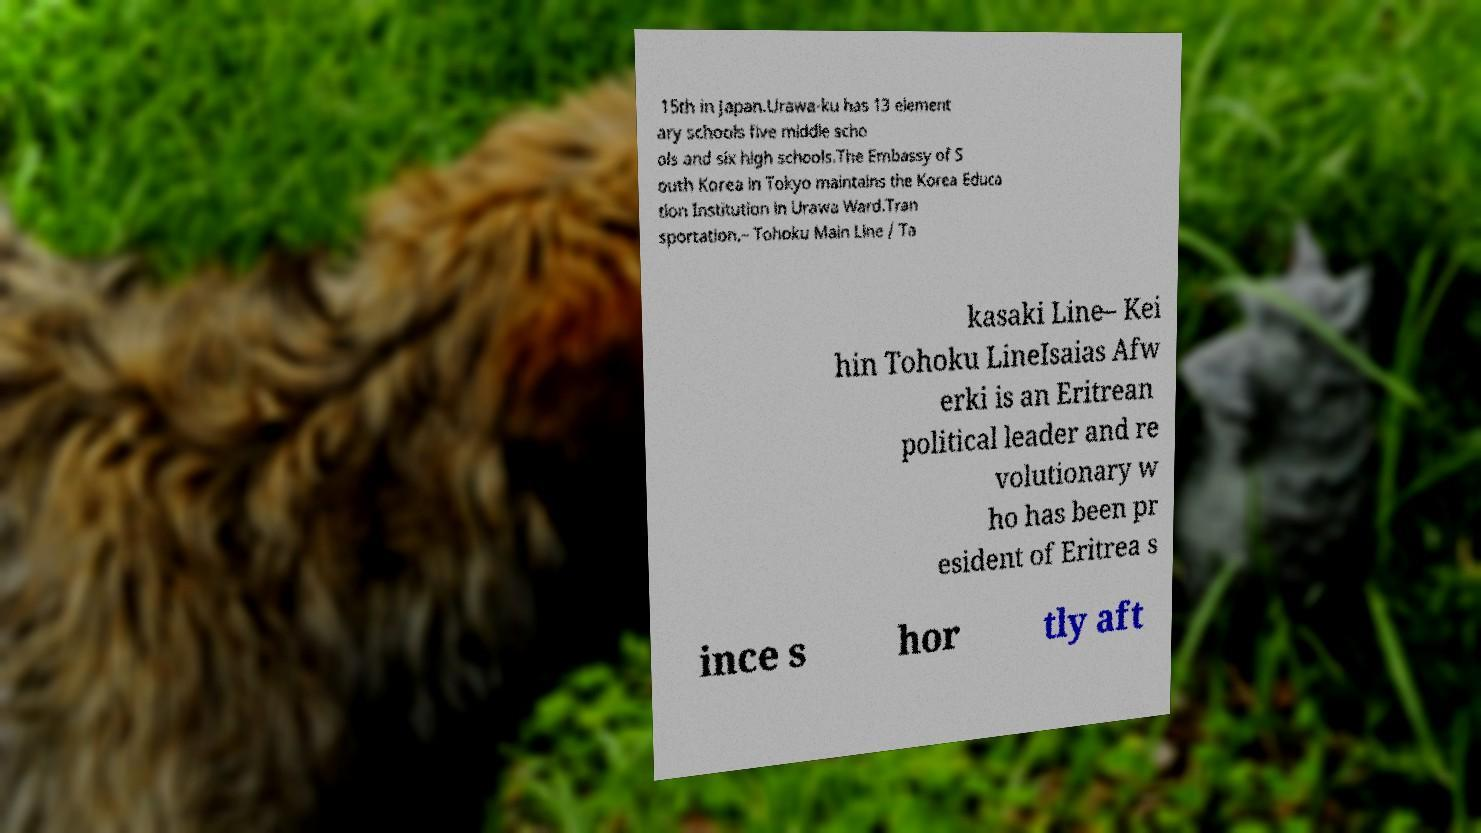Could you assist in decoding the text presented in this image and type it out clearly? 15th in Japan.Urawa-ku has 13 element ary schools five middle scho ols and six high schools.The Embassy of S outh Korea in Tokyo maintains the Korea Educa tion Institution in Urawa Ward.Tran sportation.– Tohoku Main Line / Ta kasaki Line– Kei hin Tohoku LineIsaias Afw erki is an Eritrean political leader and re volutionary w ho has been pr esident of Eritrea s ince s hor tly aft 